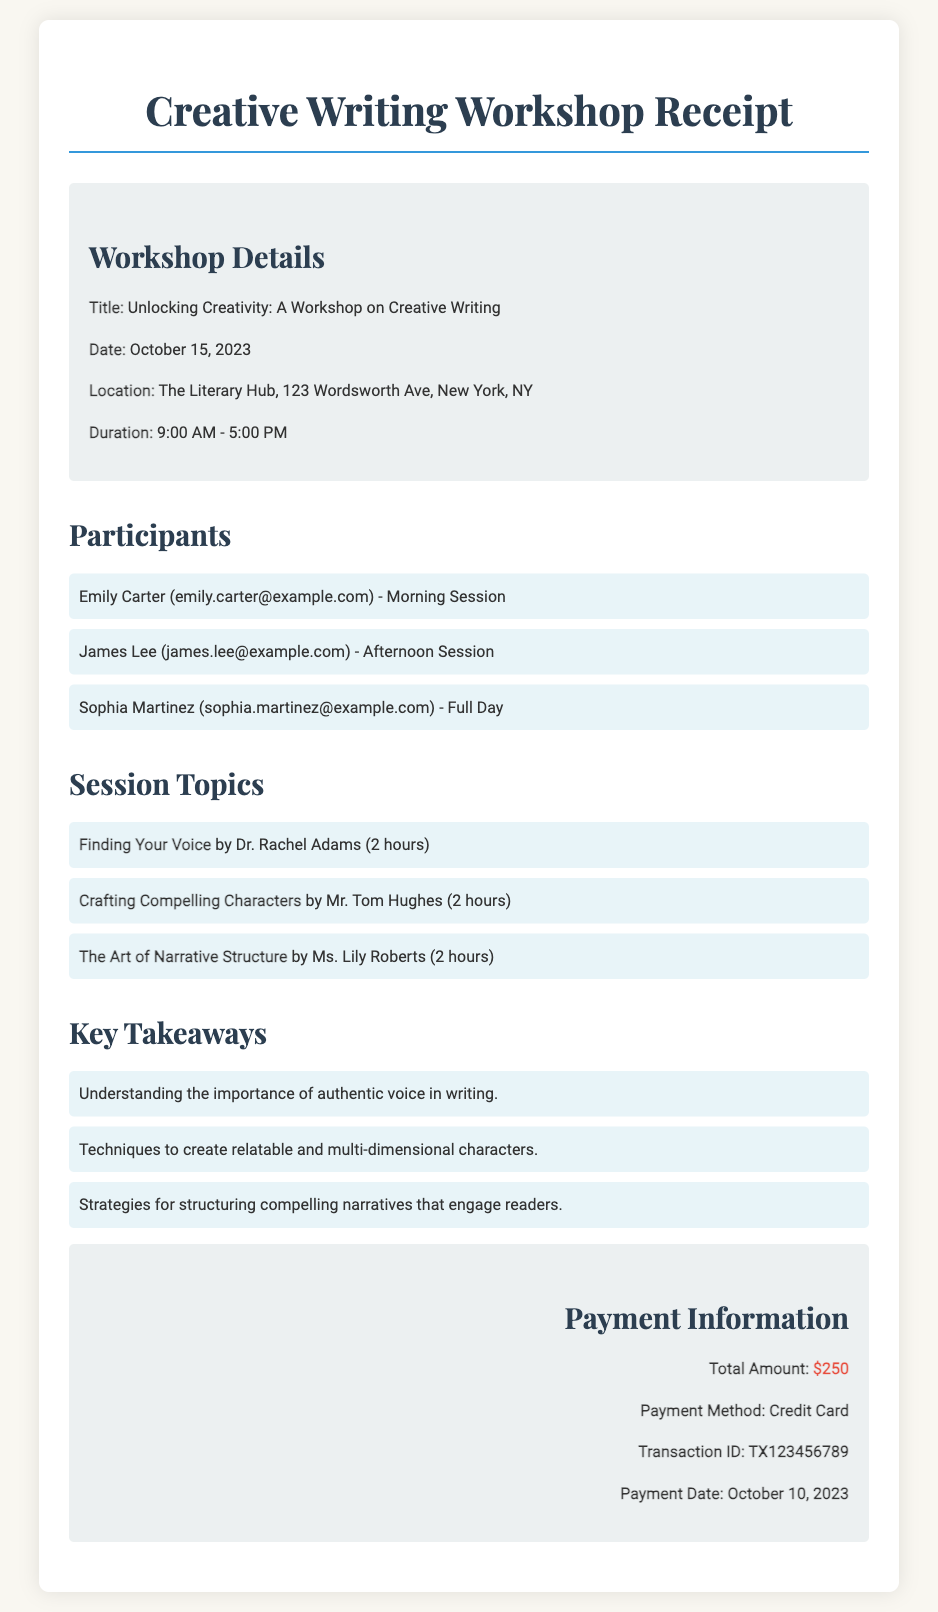What is the title of the workshop? The title of the workshop is explicitly stated in the document as "Unlocking Creativity: A Workshop on Creative Writing."
Answer: Unlocking Creativity: A Workshop on Creative Writing What is the payment amount? The document lists the total payment amount prominently in the payment information section, which is $250.
Answer: $250 Who is the instructor for "The Art of Narrative Structure"? The document specifies that "The Art of Narrative Structure" is taught by Ms. Lily Roberts.
Answer: Ms. Lily Roberts When did the workshop take place? The date of the workshop is clearly mentioned in the document as October 15, 2023.
Answer: October 15, 2023 How many key takeaways are listed? The document enumerates three key takeaways from the workshop, indicating a clear count of important points.
Answer: 3 What is the payment method used? The payment method is specified in the document, which states that the payment was made using a Credit Card.
Answer: Credit Card Which participant attended the full day? The document identifies Sophia Martinez as the participant who attended the full day session.
Answer: Sophia Martinez What are the session topics based on the document? The document lists three session topics, providing a direct insight into what was covered during the workshop.
Answer: Finding Your Voice, Crafting Compelling Characters, The Art of Narrative Structure What is the location of the workshop? The location of the workshop is detailed in the document as The Literary Hub, 123 Wordsworth Ave, New York, NY.
Answer: The Literary Hub, 123 Wordsworth Ave, New York, NY 